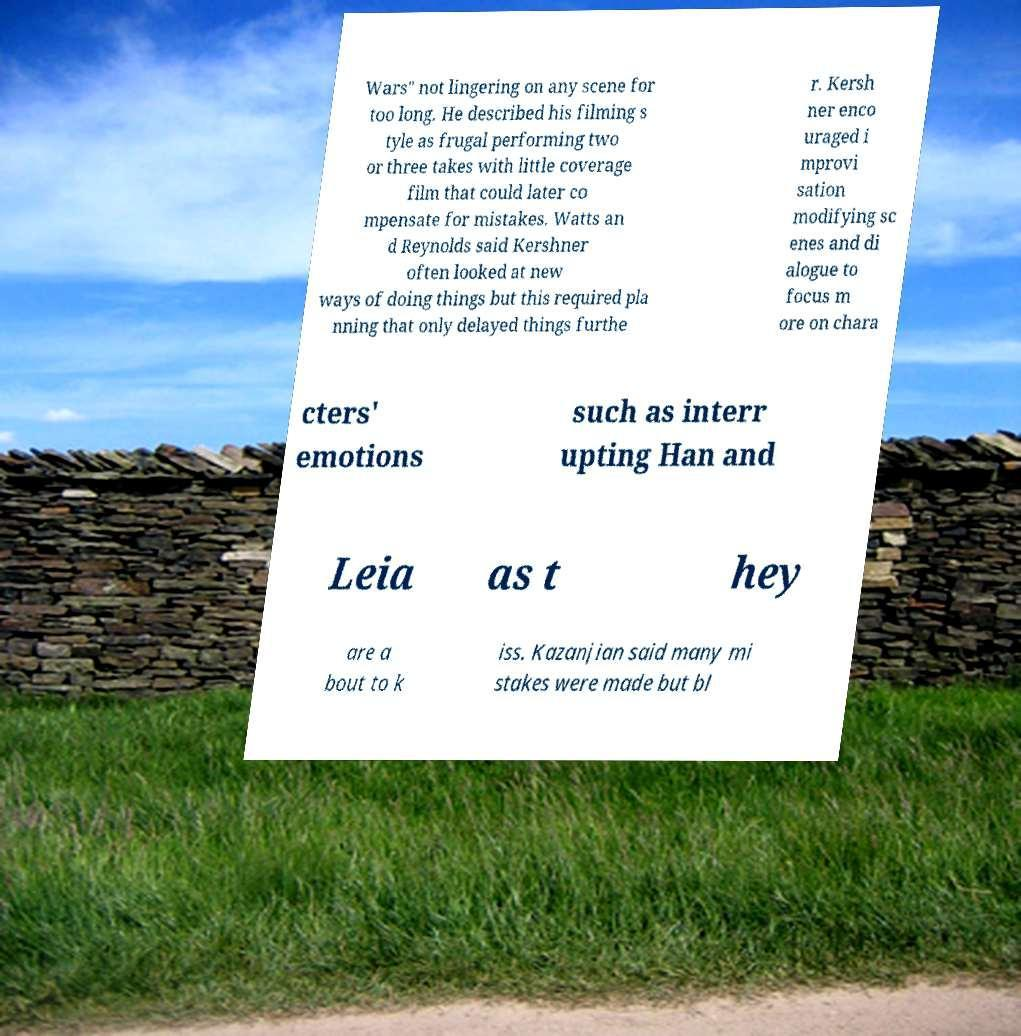Could you extract and type out the text from this image? Wars" not lingering on any scene for too long. He described his filming s tyle as frugal performing two or three takes with little coverage film that could later co mpensate for mistakes. Watts an d Reynolds said Kershner often looked at new ways of doing things but this required pla nning that only delayed things furthe r. Kersh ner enco uraged i mprovi sation modifying sc enes and di alogue to focus m ore on chara cters' emotions such as interr upting Han and Leia as t hey are a bout to k iss. Kazanjian said many mi stakes were made but bl 